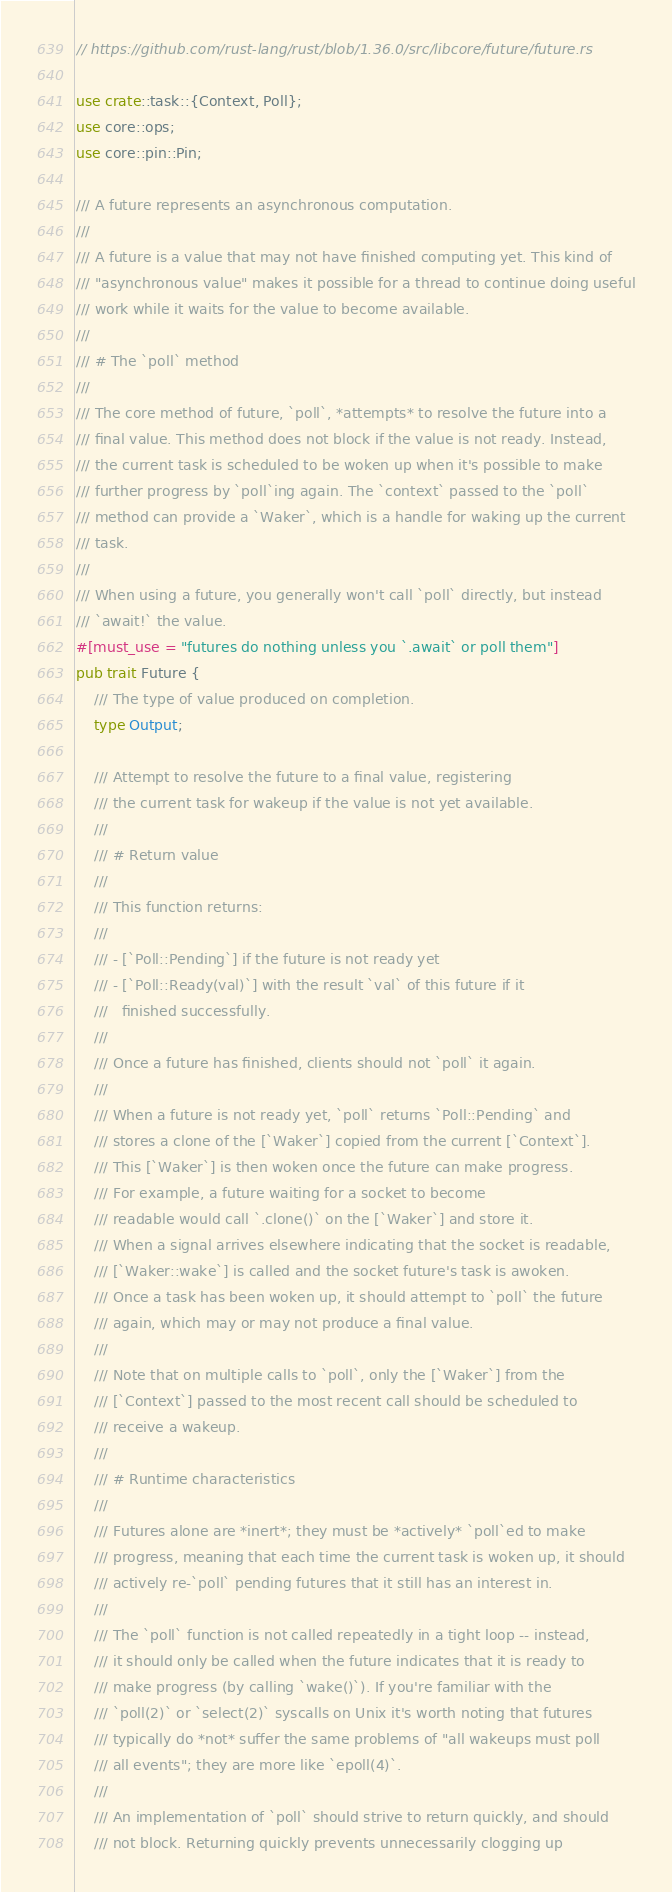Convert code to text. <code><loc_0><loc_0><loc_500><loc_500><_Rust_>// https://github.com/rust-lang/rust/blob/1.36.0/src/libcore/future/future.rs

use crate::task::{Context, Poll};
use core::ops;
use core::pin::Pin;

/// A future represents an asynchronous computation.
///
/// A future is a value that may not have finished computing yet. This kind of
/// "asynchronous value" makes it possible for a thread to continue doing useful
/// work while it waits for the value to become available.
///
/// # The `poll` method
///
/// The core method of future, `poll`, *attempts* to resolve the future into a
/// final value. This method does not block if the value is not ready. Instead,
/// the current task is scheduled to be woken up when it's possible to make
/// further progress by `poll`ing again. The `context` passed to the `poll`
/// method can provide a `Waker`, which is a handle for waking up the current
/// task.
///
/// When using a future, you generally won't call `poll` directly, but instead
/// `await!` the value.
#[must_use = "futures do nothing unless you `.await` or poll them"]
pub trait Future {
    /// The type of value produced on completion.
    type Output;

    /// Attempt to resolve the future to a final value, registering
    /// the current task for wakeup if the value is not yet available.
    ///
    /// # Return value
    ///
    /// This function returns:
    ///
    /// - [`Poll::Pending`] if the future is not ready yet
    /// - [`Poll::Ready(val)`] with the result `val` of this future if it
    ///   finished successfully.
    ///
    /// Once a future has finished, clients should not `poll` it again.
    ///
    /// When a future is not ready yet, `poll` returns `Poll::Pending` and
    /// stores a clone of the [`Waker`] copied from the current [`Context`].
    /// This [`Waker`] is then woken once the future can make progress.
    /// For example, a future waiting for a socket to become
    /// readable would call `.clone()` on the [`Waker`] and store it.
    /// When a signal arrives elsewhere indicating that the socket is readable,
    /// [`Waker::wake`] is called and the socket future's task is awoken.
    /// Once a task has been woken up, it should attempt to `poll` the future
    /// again, which may or may not produce a final value.
    ///
    /// Note that on multiple calls to `poll`, only the [`Waker`] from the
    /// [`Context`] passed to the most recent call should be scheduled to
    /// receive a wakeup.
    ///
    /// # Runtime characteristics
    ///
    /// Futures alone are *inert*; they must be *actively* `poll`ed to make
    /// progress, meaning that each time the current task is woken up, it should
    /// actively re-`poll` pending futures that it still has an interest in.
    ///
    /// The `poll` function is not called repeatedly in a tight loop -- instead,
    /// it should only be called when the future indicates that it is ready to
    /// make progress (by calling `wake()`). If you're familiar with the
    /// `poll(2)` or `select(2)` syscalls on Unix it's worth noting that futures
    /// typically do *not* suffer the same problems of "all wakeups must poll
    /// all events"; they are more like `epoll(4)`.
    ///
    /// An implementation of `poll` should strive to return quickly, and should
    /// not block. Returning quickly prevents unnecessarily clogging up</code> 